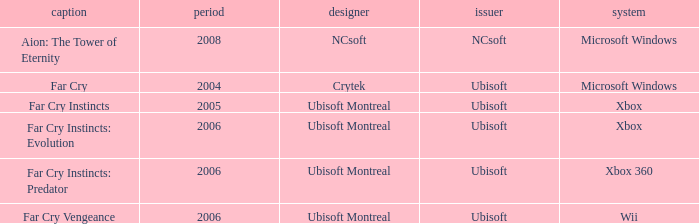Which developer has xbox 360 as the platform? Ubisoft Montreal. 